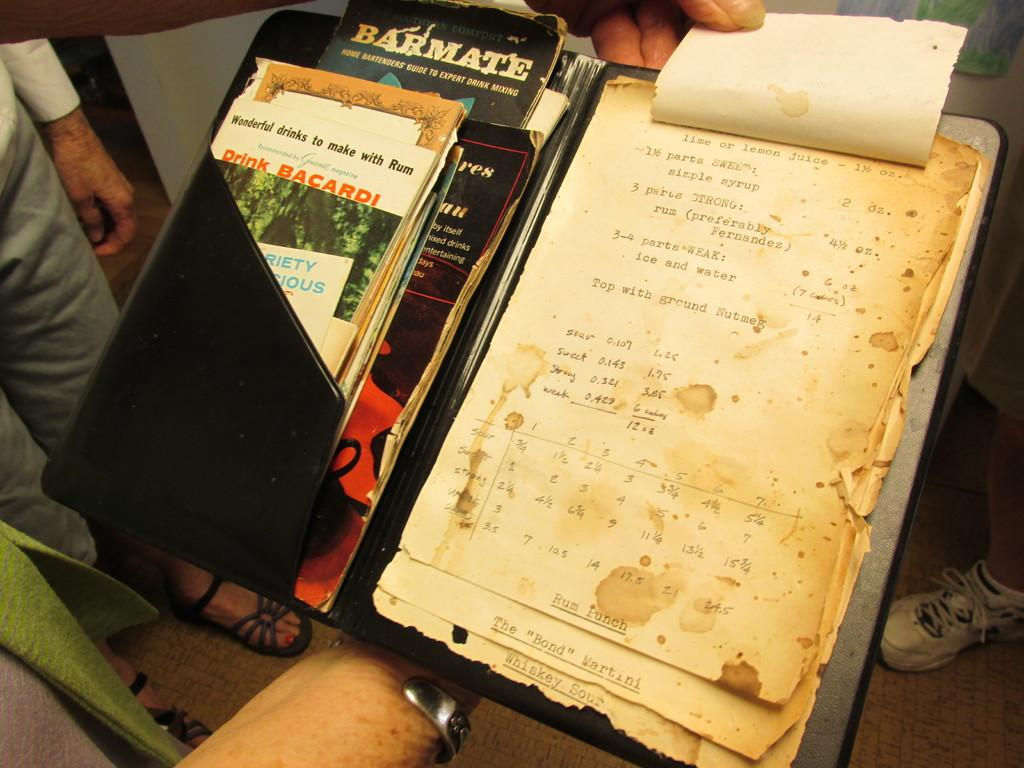<image>
Relay a brief, clear account of the picture shown. A very old, worn out recipe for Rum Punch. 